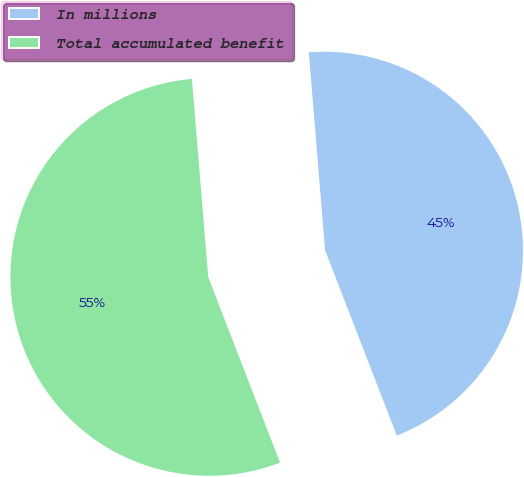<chart> <loc_0><loc_0><loc_500><loc_500><pie_chart><fcel>In millions<fcel>Total accumulated benefit<nl><fcel>45.43%<fcel>54.57%<nl></chart> 